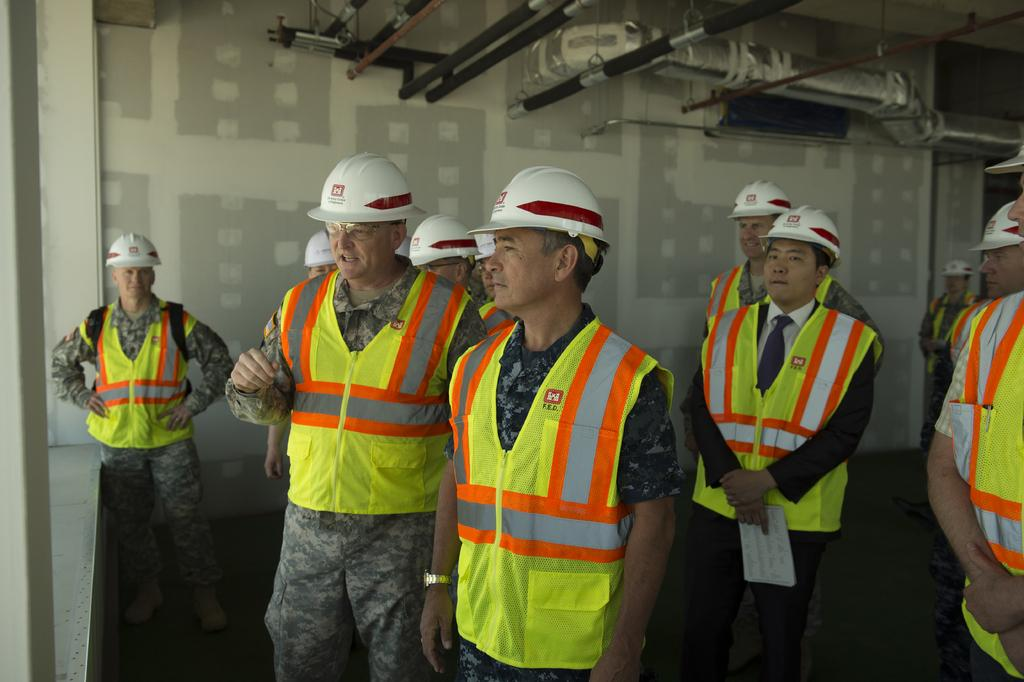Who or what is present in the image? There are people in the image. What are the people wearing on their heads? The people are wearing helmets. What can be seen in the background of the image? There is a wall in the background of the image. What type of material is visible in the image? Metal rods are present in the image. What direction are the people playing volleyball in the image? There is no volleyball present in the image, so it is not possible to determine the direction in which the people are playing. 